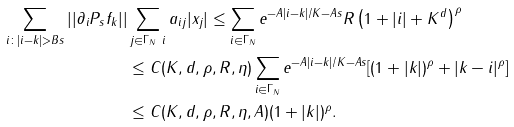<formula> <loc_0><loc_0><loc_500><loc_500>\sum _ { i \colon | i - k | > B s } | | \partial _ { i } P _ { s } f _ { k } | | & \sum _ { j \in \Gamma _ { N } \ i } a _ { i j } | x _ { j } | \leq \sum _ { i \in \Gamma _ { N } } e ^ { - A | i - k | / K - A s } R \left ( 1 + | i | + K ^ { d } \right ) ^ { \rho } \\ & \leq C ( K , d , \rho , R , \eta ) \sum _ { i \in \Gamma _ { N } } e ^ { - A | i - k | / K - A s } [ ( 1 + | k | ) ^ { \rho } + | k - i | ^ { \rho } ] \\ & \leq C ( K , d , \rho , R , \eta , A ) ( 1 + | k | ) ^ { \rho } .</formula> 